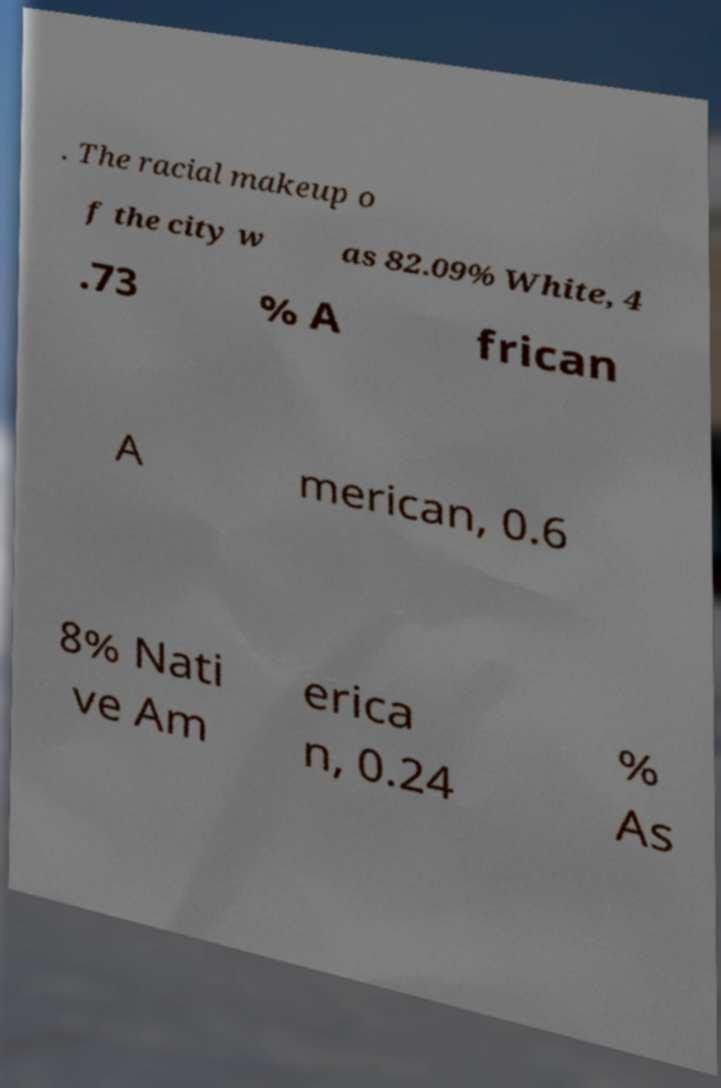For documentation purposes, I need the text within this image transcribed. Could you provide that? . The racial makeup o f the city w as 82.09% White, 4 .73 % A frican A merican, 0.6 8% Nati ve Am erica n, 0.24 % As 